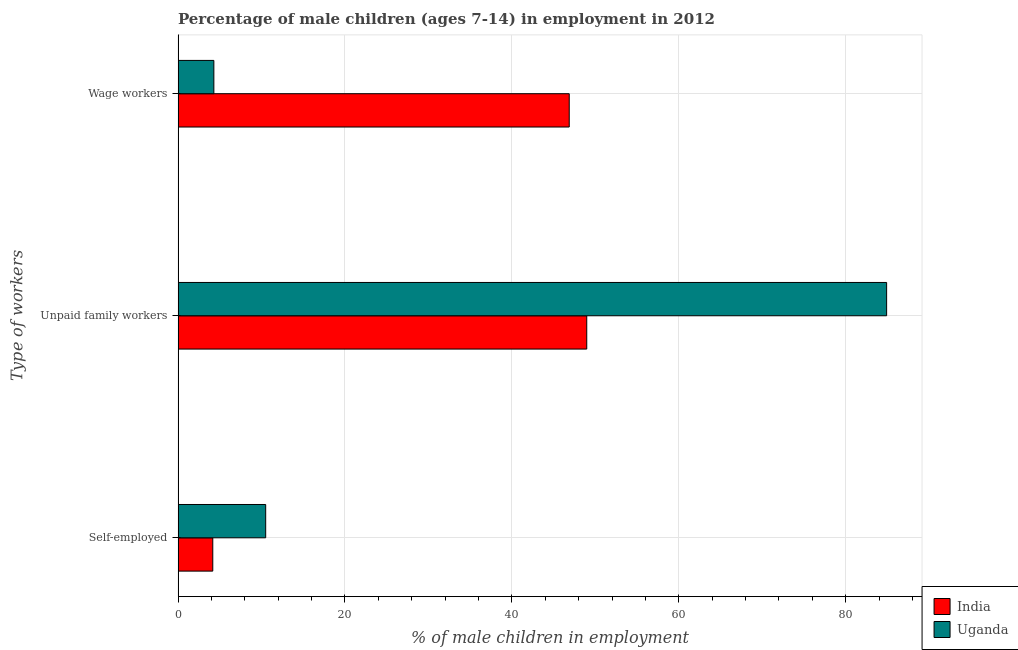How many groups of bars are there?
Provide a succinct answer. 3. What is the label of the 2nd group of bars from the top?
Give a very brief answer. Unpaid family workers. What is the percentage of children employed as unpaid family workers in Uganda?
Give a very brief answer. 84.9. Across all countries, what is the maximum percentage of children employed as unpaid family workers?
Offer a terse response. 84.9. Across all countries, what is the minimum percentage of children employed as wage workers?
Provide a succinct answer. 4.29. What is the total percentage of children employed as wage workers in the graph?
Your answer should be very brief. 51.16. What is the difference between the percentage of children employed as wage workers in Uganda and that in India?
Ensure brevity in your answer.  -42.58. What is the difference between the percentage of children employed as unpaid family workers in India and the percentage of self employed children in Uganda?
Keep it short and to the point. 38.47. What is the average percentage of children employed as unpaid family workers per country?
Your response must be concise. 66.94. What is the difference between the percentage of children employed as unpaid family workers and percentage of self employed children in Uganda?
Offer a very short reply. 74.4. In how many countries, is the percentage of children employed as unpaid family workers greater than 32 %?
Keep it short and to the point. 2. What is the ratio of the percentage of children employed as unpaid family workers in Uganda to that in India?
Give a very brief answer. 1.73. Is the percentage of children employed as wage workers in India less than that in Uganda?
Give a very brief answer. No. What is the difference between the highest and the second highest percentage of children employed as unpaid family workers?
Your answer should be very brief. 35.93. What is the difference between the highest and the lowest percentage of children employed as unpaid family workers?
Ensure brevity in your answer.  35.93. Is the sum of the percentage of children employed as wage workers in India and Uganda greater than the maximum percentage of children employed as unpaid family workers across all countries?
Offer a terse response. No. What does the 1st bar from the top in Self-employed represents?
Provide a short and direct response. Uganda. How many bars are there?
Your answer should be compact. 6. Are all the bars in the graph horizontal?
Keep it short and to the point. Yes. How many countries are there in the graph?
Offer a very short reply. 2. What is the difference between two consecutive major ticks on the X-axis?
Offer a very short reply. 20. Does the graph contain any zero values?
Your answer should be very brief. No. How many legend labels are there?
Offer a terse response. 2. What is the title of the graph?
Your response must be concise. Percentage of male children (ages 7-14) in employment in 2012. What is the label or title of the X-axis?
Ensure brevity in your answer.  % of male children in employment. What is the label or title of the Y-axis?
Provide a succinct answer. Type of workers. What is the % of male children in employment of India in Self-employed?
Give a very brief answer. 4.16. What is the % of male children in employment in India in Unpaid family workers?
Your answer should be very brief. 48.97. What is the % of male children in employment in Uganda in Unpaid family workers?
Provide a succinct answer. 84.9. What is the % of male children in employment in India in Wage workers?
Give a very brief answer. 46.87. What is the % of male children in employment in Uganda in Wage workers?
Provide a short and direct response. 4.29. Across all Type of workers, what is the maximum % of male children in employment in India?
Provide a short and direct response. 48.97. Across all Type of workers, what is the maximum % of male children in employment in Uganda?
Keep it short and to the point. 84.9. Across all Type of workers, what is the minimum % of male children in employment of India?
Offer a very short reply. 4.16. Across all Type of workers, what is the minimum % of male children in employment in Uganda?
Keep it short and to the point. 4.29. What is the total % of male children in employment in India in the graph?
Your answer should be compact. 100. What is the total % of male children in employment of Uganda in the graph?
Offer a very short reply. 99.69. What is the difference between the % of male children in employment in India in Self-employed and that in Unpaid family workers?
Your response must be concise. -44.81. What is the difference between the % of male children in employment of Uganda in Self-employed and that in Unpaid family workers?
Ensure brevity in your answer.  -74.4. What is the difference between the % of male children in employment of India in Self-employed and that in Wage workers?
Keep it short and to the point. -42.71. What is the difference between the % of male children in employment in Uganda in Self-employed and that in Wage workers?
Give a very brief answer. 6.21. What is the difference between the % of male children in employment in India in Unpaid family workers and that in Wage workers?
Your answer should be compact. 2.1. What is the difference between the % of male children in employment in Uganda in Unpaid family workers and that in Wage workers?
Your answer should be compact. 80.61. What is the difference between the % of male children in employment in India in Self-employed and the % of male children in employment in Uganda in Unpaid family workers?
Keep it short and to the point. -80.74. What is the difference between the % of male children in employment of India in Self-employed and the % of male children in employment of Uganda in Wage workers?
Offer a terse response. -0.13. What is the difference between the % of male children in employment in India in Unpaid family workers and the % of male children in employment in Uganda in Wage workers?
Keep it short and to the point. 44.68. What is the average % of male children in employment of India per Type of workers?
Offer a terse response. 33.33. What is the average % of male children in employment in Uganda per Type of workers?
Provide a succinct answer. 33.23. What is the difference between the % of male children in employment in India and % of male children in employment in Uganda in Self-employed?
Your answer should be very brief. -6.34. What is the difference between the % of male children in employment of India and % of male children in employment of Uganda in Unpaid family workers?
Give a very brief answer. -35.93. What is the difference between the % of male children in employment of India and % of male children in employment of Uganda in Wage workers?
Give a very brief answer. 42.58. What is the ratio of the % of male children in employment in India in Self-employed to that in Unpaid family workers?
Provide a short and direct response. 0.08. What is the ratio of the % of male children in employment of Uganda in Self-employed to that in Unpaid family workers?
Provide a succinct answer. 0.12. What is the ratio of the % of male children in employment of India in Self-employed to that in Wage workers?
Your response must be concise. 0.09. What is the ratio of the % of male children in employment of Uganda in Self-employed to that in Wage workers?
Make the answer very short. 2.45. What is the ratio of the % of male children in employment of India in Unpaid family workers to that in Wage workers?
Your answer should be compact. 1.04. What is the ratio of the % of male children in employment of Uganda in Unpaid family workers to that in Wage workers?
Your answer should be compact. 19.79. What is the difference between the highest and the second highest % of male children in employment of Uganda?
Make the answer very short. 74.4. What is the difference between the highest and the lowest % of male children in employment in India?
Make the answer very short. 44.81. What is the difference between the highest and the lowest % of male children in employment of Uganda?
Keep it short and to the point. 80.61. 